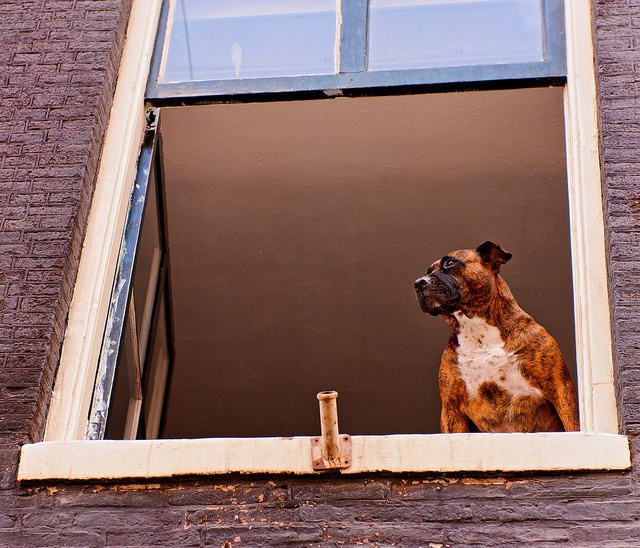Describe the objects in this image and their specific colors. I can see a dog in gray, maroon, brown, black, and tan tones in this image. 